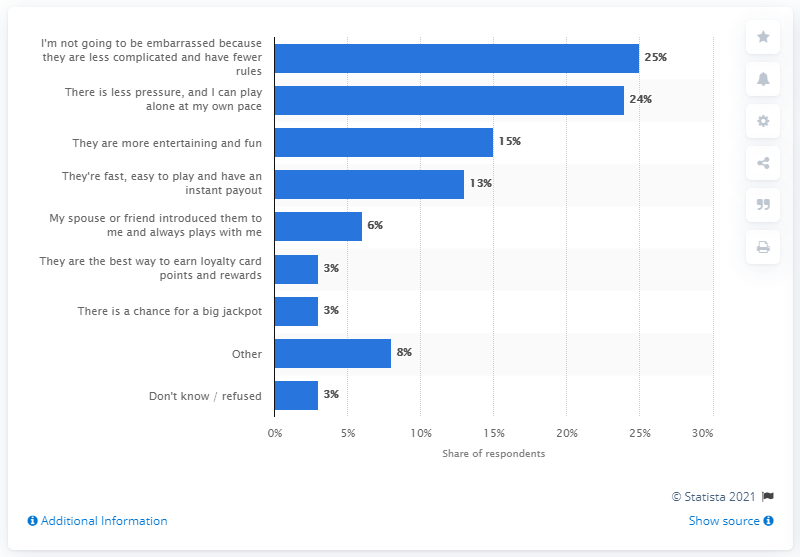Indicate a few pertinent items in this graphic. According to the source, 15 people say that they are more entertaining and fun. According to the interviewees, slot machines were preferred over table games by 13% of them. The average of the four highest values is 19.25. 